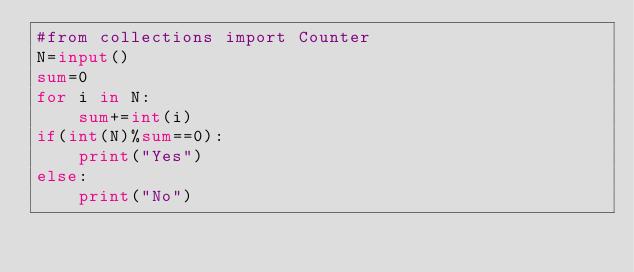Convert code to text. <code><loc_0><loc_0><loc_500><loc_500><_Python_>#from collections import Counter
N=input()
sum=0
for i in N:
    sum+=int(i)
if(int(N)%sum==0):
    print("Yes")
else:
    print("No")</code> 